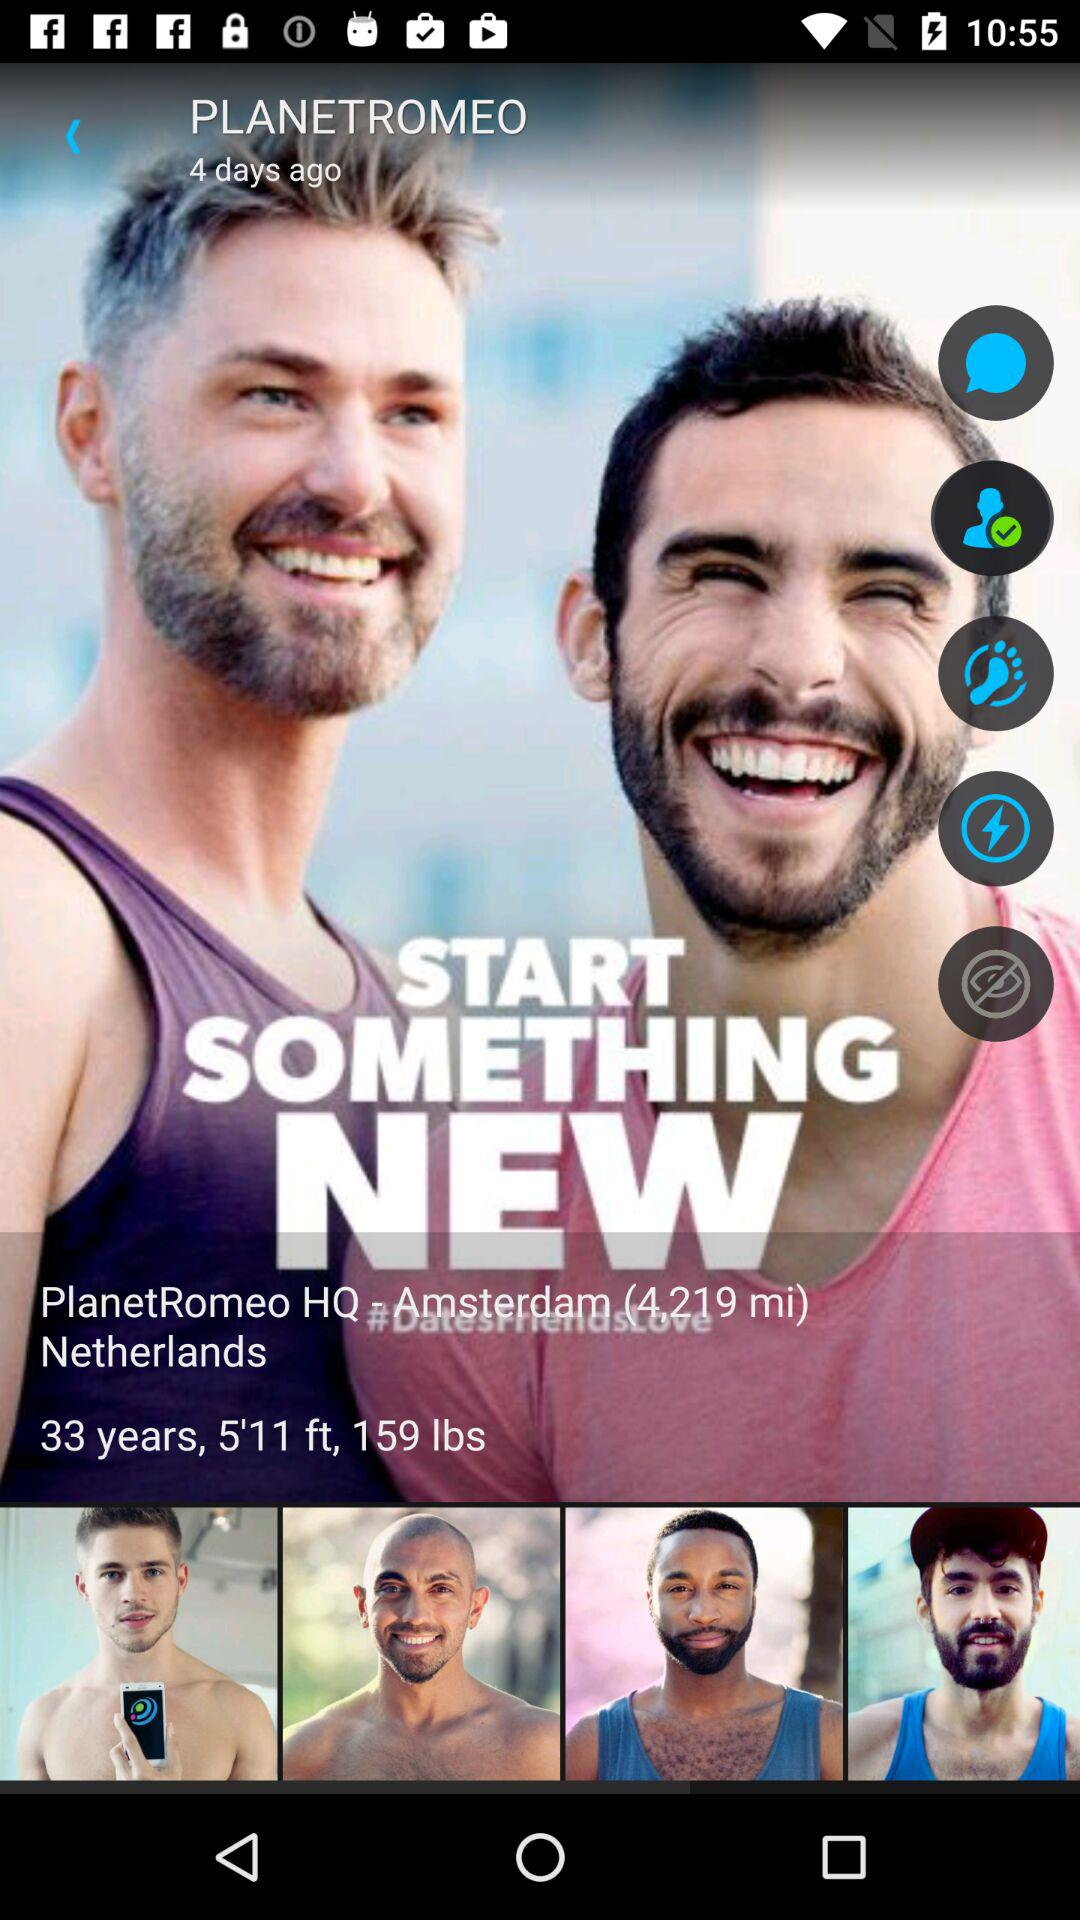What is the weight of PlanetRomeo? The weight of the PlanetRomeo is 159 lbs. 